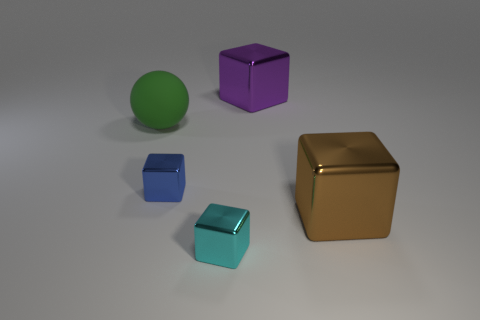How many big rubber things are the same color as the rubber ball?
Ensure brevity in your answer.  0. Does the metallic object in front of the brown thing have the same shape as the brown metal thing?
Your answer should be compact. Yes. Are there fewer large metallic objects that are behind the big brown cube than large cubes left of the cyan thing?
Keep it short and to the point. No. There is a block that is left of the tiny cyan shiny cube; what is it made of?
Your answer should be very brief. Metal. Are there any green things that have the same size as the matte ball?
Give a very brief answer. No. There is a large brown thing; is its shape the same as the blue shiny object to the left of the cyan cube?
Make the answer very short. Yes. There is a object that is right of the big purple shiny block; does it have the same size as the metal cube that is left of the cyan object?
Provide a short and direct response. No. How many other things are the same shape as the purple thing?
Make the answer very short. 3. The big thing to the left of the big thing that is behind the big rubber ball is made of what material?
Provide a short and direct response. Rubber. How many metal things are either brown cubes or big purple things?
Offer a very short reply. 2. 